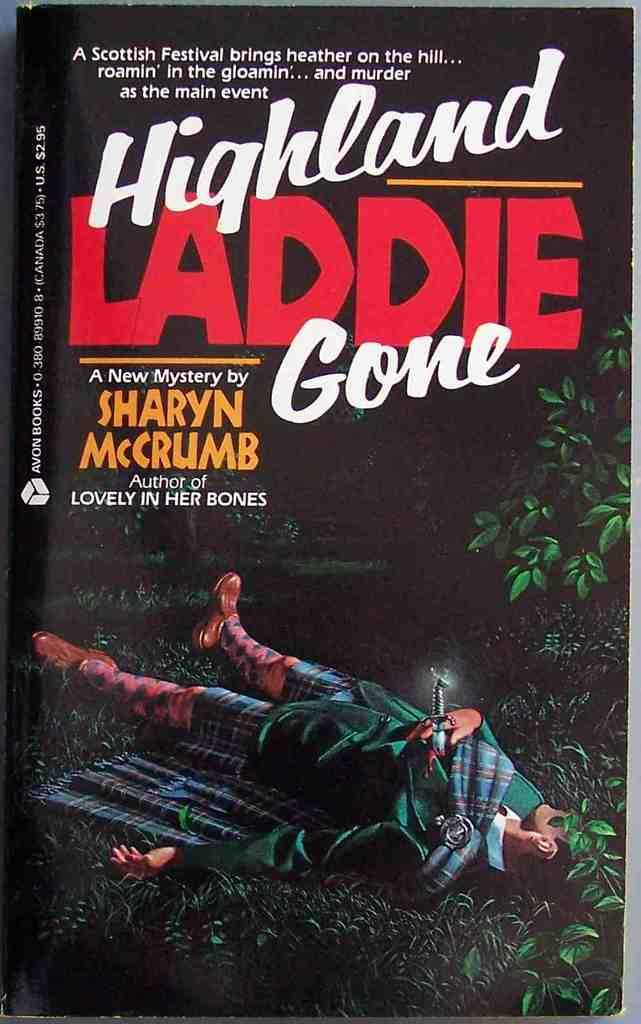<image>
Offer a succinct explanation of the picture presented. Book cover for Highland Laddie Gone written by Sharyn Mccrumb. 